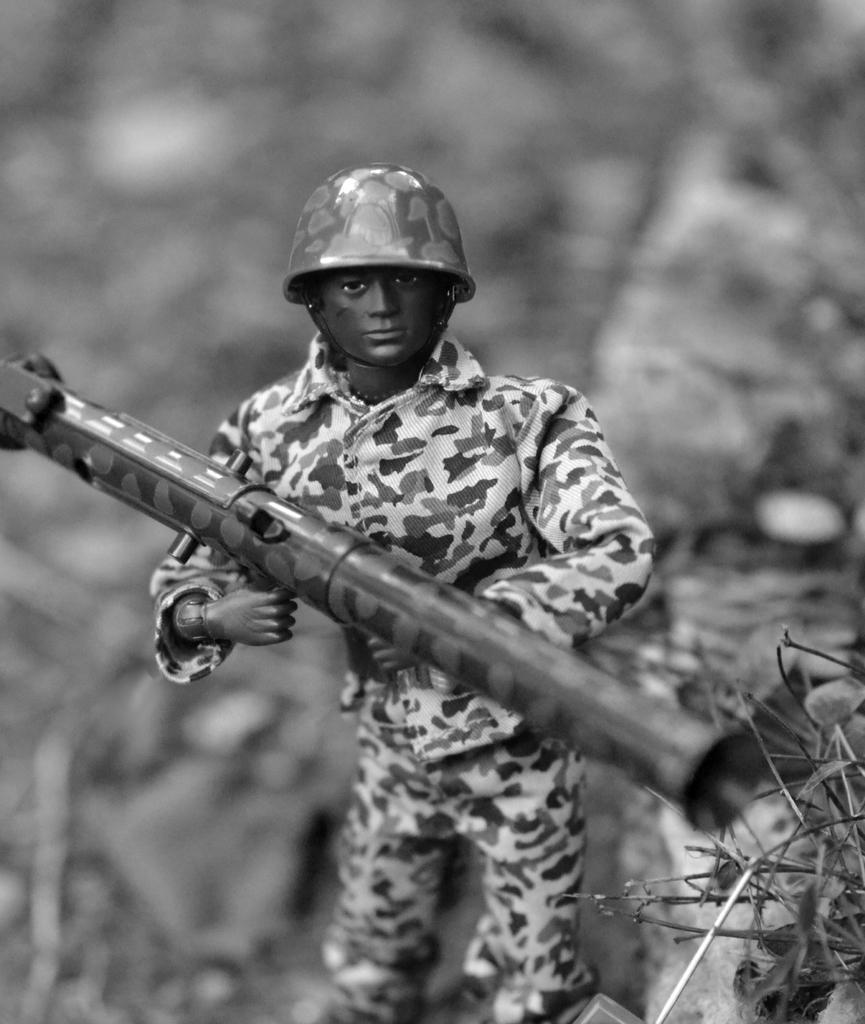Please provide a concise description of this image. In this image we can see a black and white picture of a doll holding gun in its hand. 